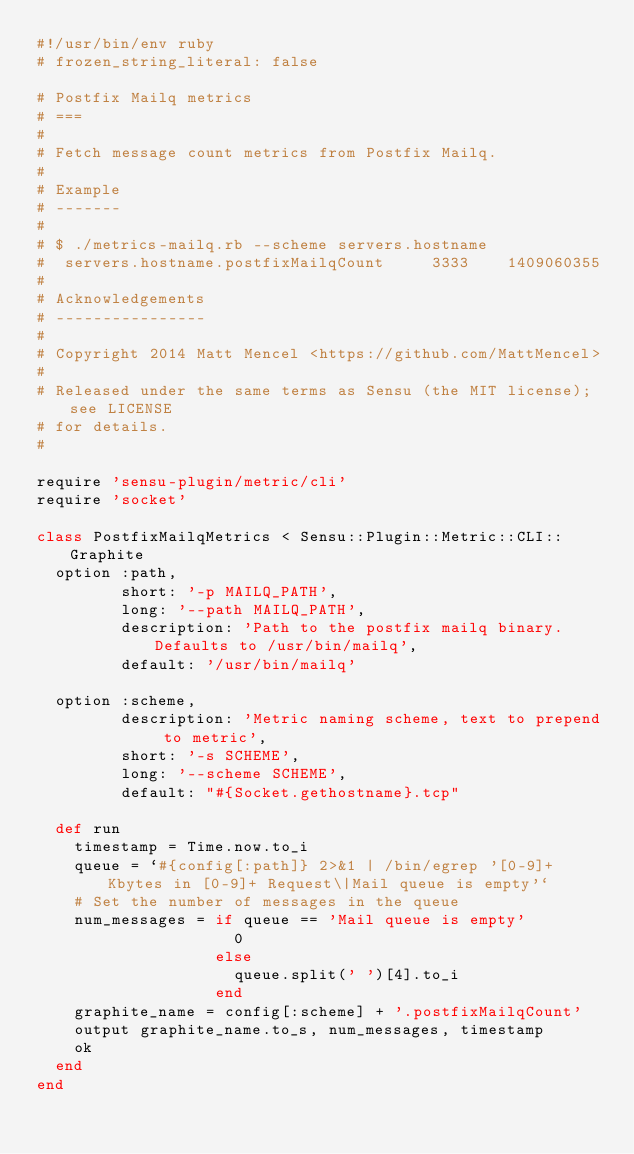<code> <loc_0><loc_0><loc_500><loc_500><_Ruby_>#!/usr/bin/env ruby
# frozen_string_literal: false

# Postfix Mailq metrics
# ===
#
# Fetch message count metrics from Postfix Mailq.
#
# Example
# -------
#
# $ ./metrics-mailq.rb --scheme servers.hostname
#  servers.hostname.postfixMailqCount     3333    1409060355
#
# Acknowledgements
# ----------------
#
# Copyright 2014 Matt Mencel <https://github.com/MattMencel>
#
# Released under the same terms as Sensu (the MIT license); see LICENSE
# for details.
#

require 'sensu-plugin/metric/cli'
require 'socket'

class PostfixMailqMetrics < Sensu::Plugin::Metric::CLI::Graphite
  option :path,
         short: '-p MAILQ_PATH',
         long: '--path MAILQ_PATH',
         description: 'Path to the postfix mailq binary.  Defaults to /usr/bin/mailq',
         default: '/usr/bin/mailq'

  option :scheme,
         description: 'Metric naming scheme, text to prepend to metric',
         short: '-s SCHEME',
         long: '--scheme SCHEME',
         default: "#{Socket.gethostname}.tcp"

  def run
    timestamp = Time.now.to_i
    queue = `#{config[:path]} 2>&1 | /bin/egrep '[0-9]+ Kbytes in [0-9]+ Request\|Mail queue is empty'`
    # Set the number of messages in the queue
    num_messages = if queue == 'Mail queue is empty'
                     0
                   else
                     queue.split(' ')[4].to_i
                   end
    graphite_name = config[:scheme] + '.postfixMailqCount'
    output graphite_name.to_s, num_messages, timestamp
    ok
  end
end
</code> 